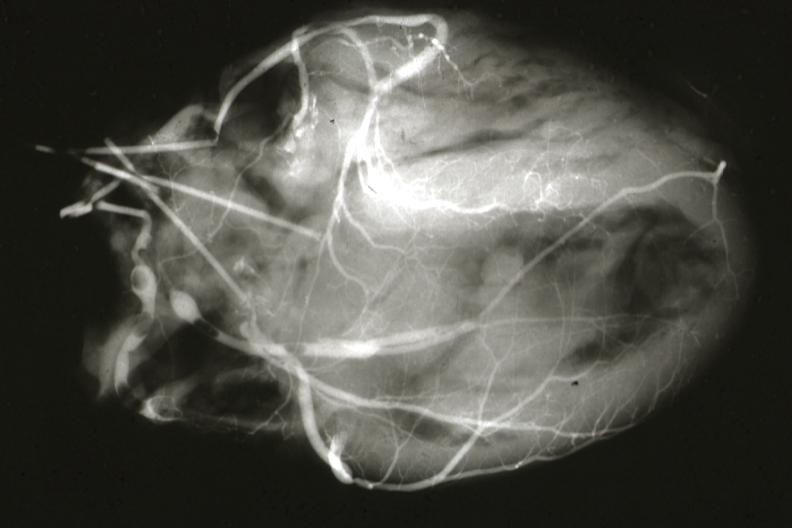s quite good liver present?
Answer the question using a single word or phrase. No 